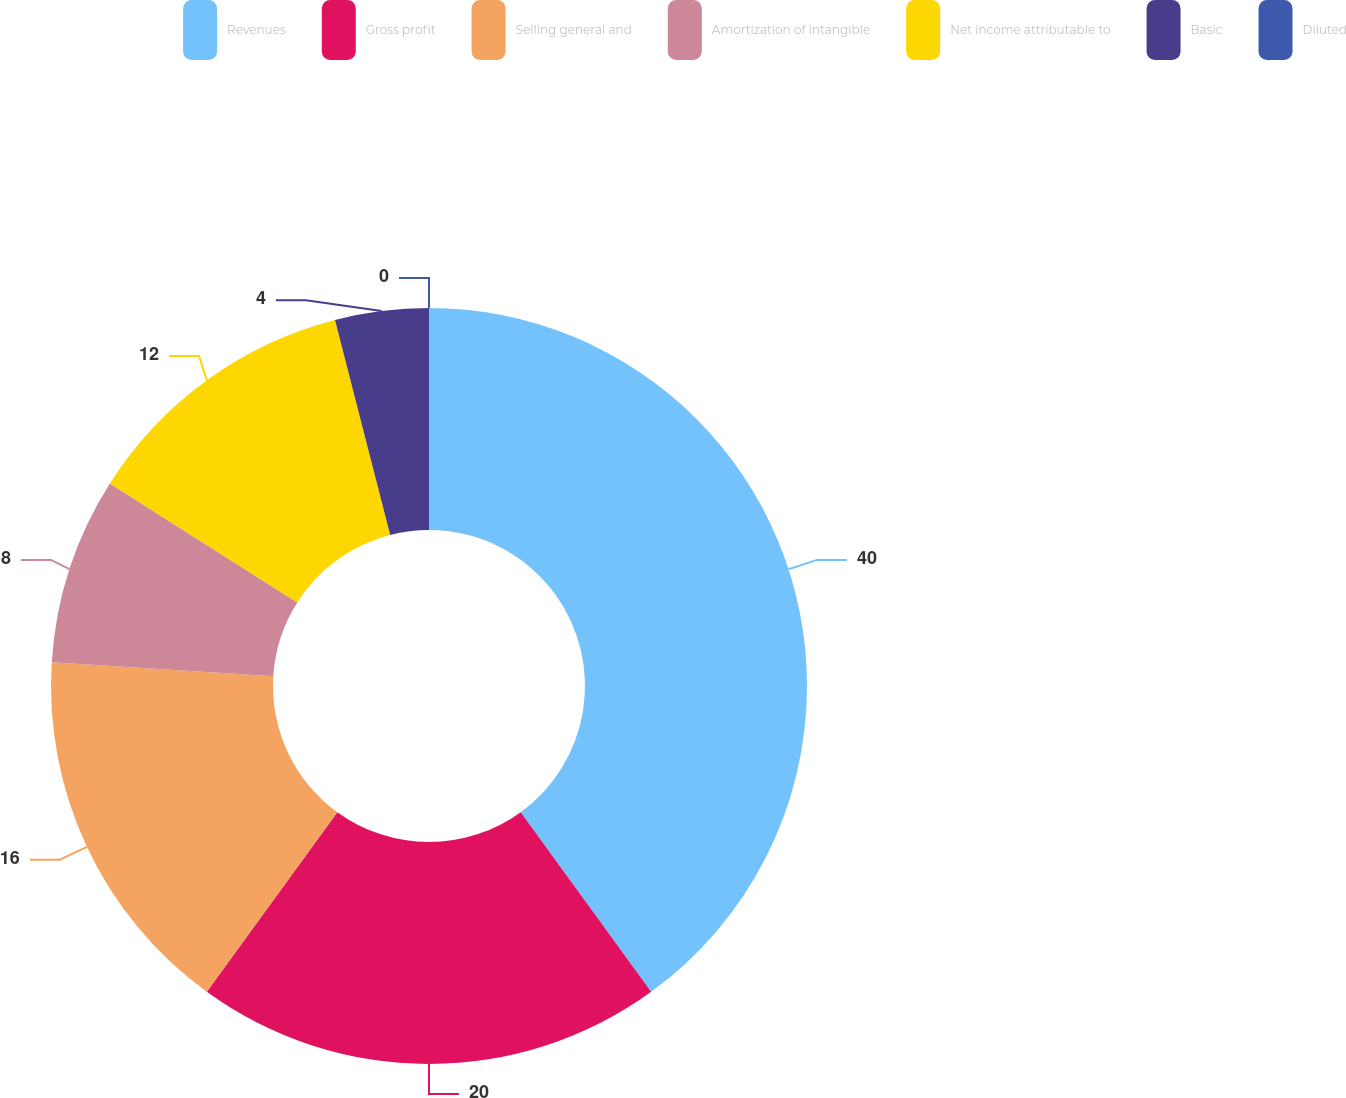Convert chart to OTSL. <chart><loc_0><loc_0><loc_500><loc_500><pie_chart><fcel>Revenues<fcel>Gross profit<fcel>Selling general and<fcel>Amortization of intangible<fcel>Net income attributable to<fcel>Basic<fcel>Diluted<nl><fcel>40.0%<fcel>20.0%<fcel>16.0%<fcel>8.0%<fcel>12.0%<fcel>4.0%<fcel>0.0%<nl></chart> 